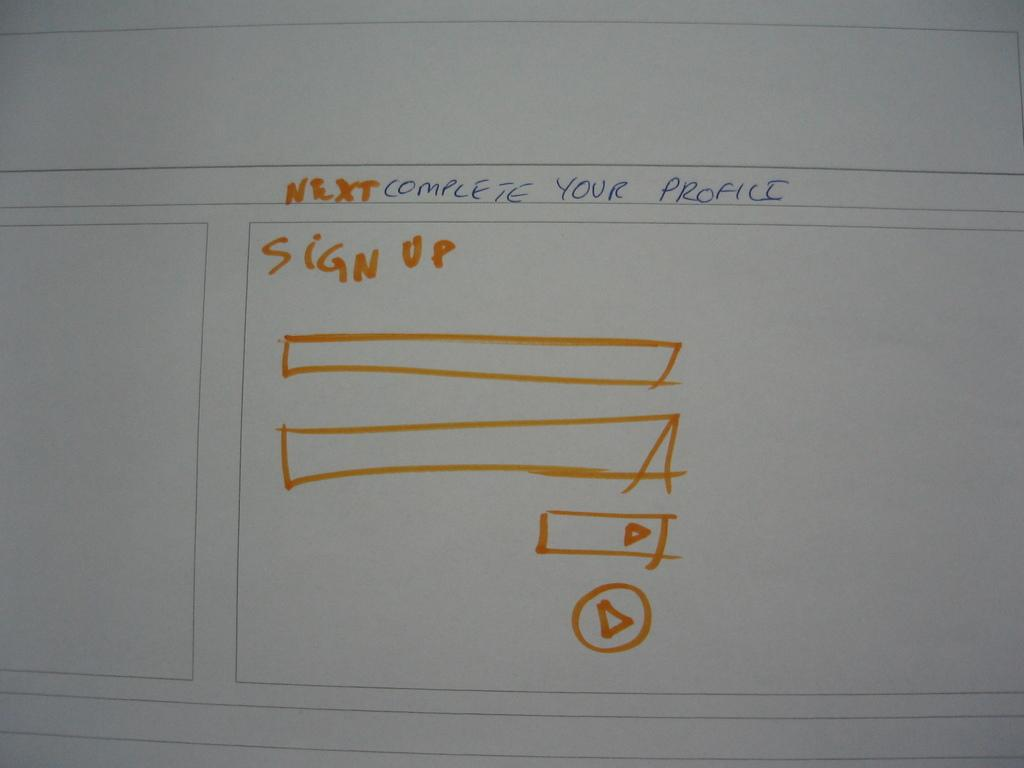What is the color of the main object in the image? The main object in the image is white. What is written on the white object? There is writing on the white object. What colors are used for the writing? The writing is in blue and orange colors. Is there any hair visible on the white object in the image? There is no mention of hair in the provided facts, so we cannot determine if hair is visible on the white object in the image. 